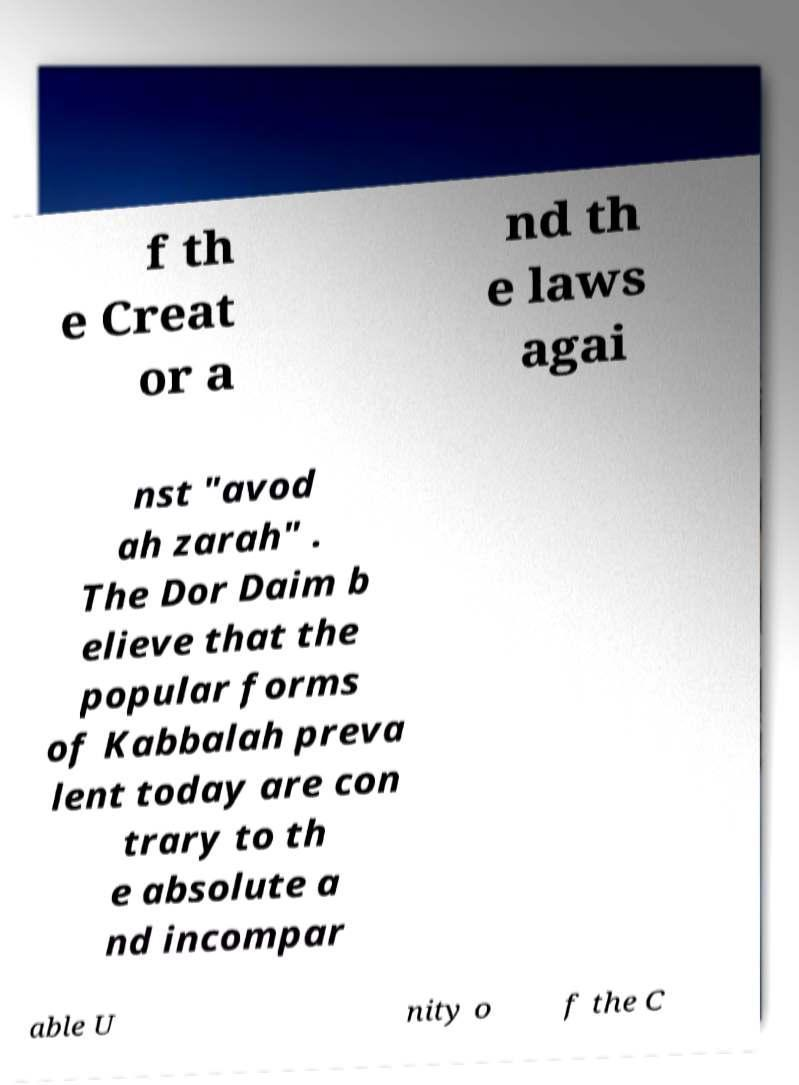What messages or text are displayed in this image? I need them in a readable, typed format. f th e Creat or a nd th e laws agai nst "avod ah zarah" . The Dor Daim b elieve that the popular forms of Kabbalah preva lent today are con trary to th e absolute a nd incompar able U nity o f the C 